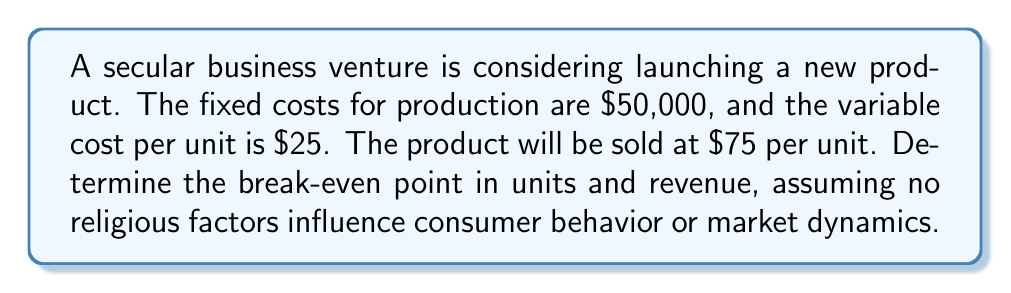Show me your answer to this math problem. To calculate the break-even point, we need to determine the number of units at which total revenue equals total costs. Let's approach this step-by-step:

1. Define variables:
   $x$ = number of units
   $P$ = price per unit = $75
   $V$ = variable cost per unit = $25
   $F$ = fixed costs = $50,000

2. Set up the break-even equation:
   Total Revenue = Total Costs
   $Px = F + Vx$

3. Substitute known values:
   $75x = 50,000 + 25x$

4. Solve for $x$:
   $75x - 25x = 50,000$
   $50x = 50,000$
   $x = 1,000$ units

5. Calculate break-even revenue:
   Revenue = Price × Units
   $R = 75 × 1,000 = 75,000$

Therefore, the business needs to sell 1,000 units to break even, which corresponds to $75,000 in revenue.

To verify, we can check that total costs equal total revenue at this point:
Total Costs = Fixed Costs + (Variable Cost × Units)
$$ 50,000 + (25 × 1,000) = 50,000 + 25,000 = 75,000 $$

This equals the calculated break-even revenue, confirming our result.
Answer: Break-even point: 1,000 units
Break-even revenue: $75,000 